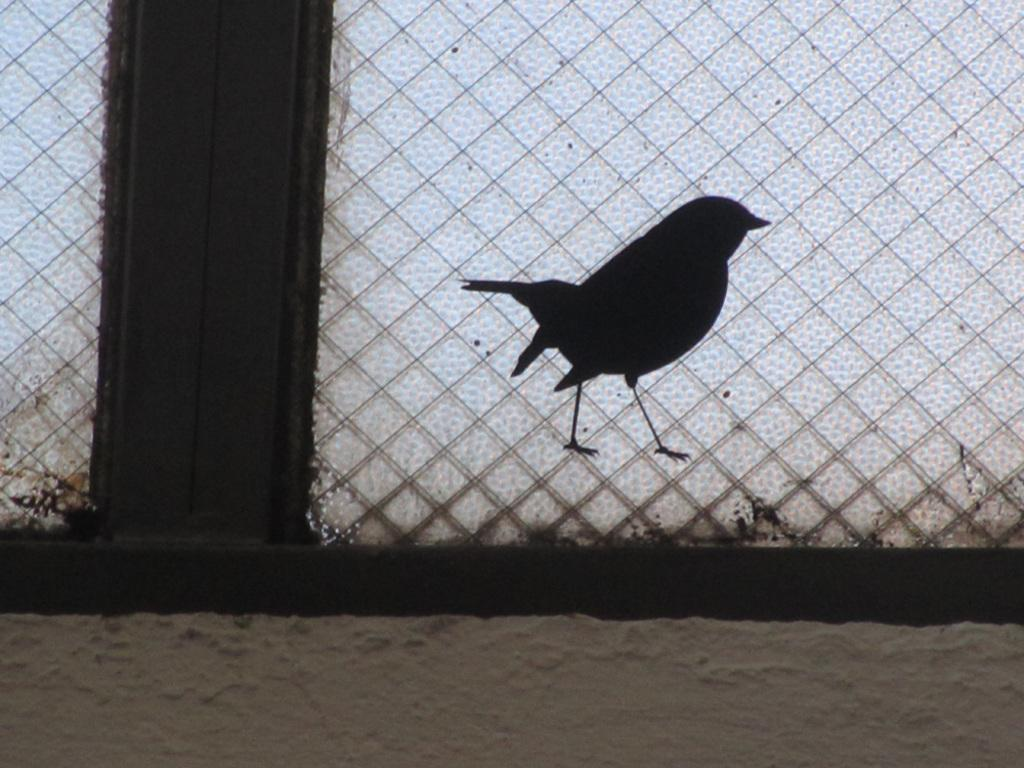What is located in the center of the image? There is a window in the center of the image. Can you describe anything near the window? There is a shadow of a bird near the window. What type of surface is visible at the bottom of the image? There is sand at the bottom of the image. What type of lead can be seen in the image? There is no lead present in the image. 